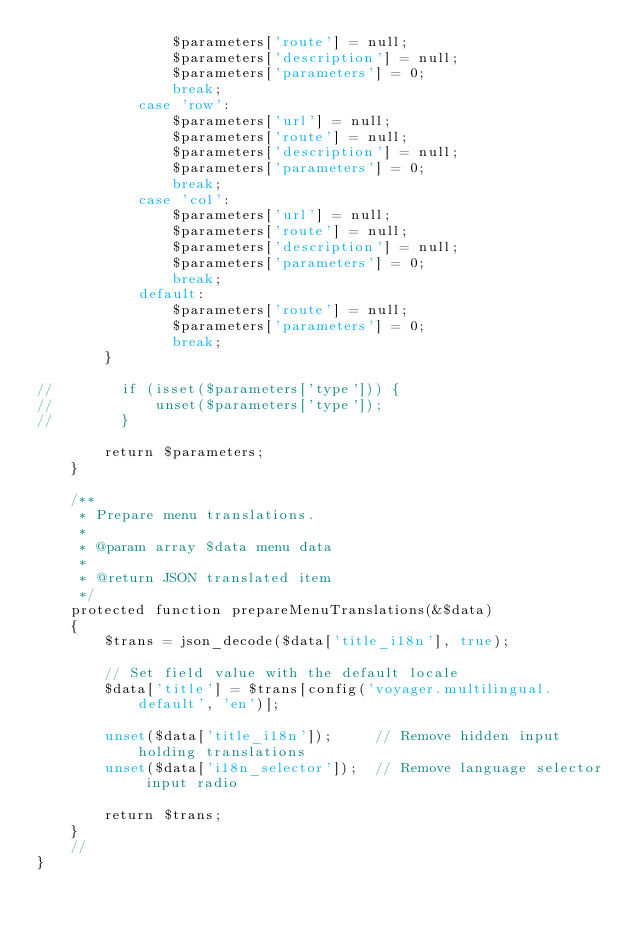Convert code to text. <code><loc_0><loc_0><loc_500><loc_500><_PHP_>                $parameters['route'] = null;
                $parameters['description'] = null;
                $parameters['parameters'] = 0;
                break;
            case 'row':
                $parameters['url'] = null;
                $parameters['route'] = null;
                $parameters['description'] = null;
                $parameters['parameters'] = 0;
                break;
            case 'col':
                $parameters['url'] = null;
                $parameters['route'] = null;
                $parameters['description'] = null;
                $parameters['parameters'] = 0;
                break;
            default:
                $parameters['route'] = null;
                $parameters['parameters'] = 0;
                break;
        }

//        if (isset($parameters['type'])) {
//            unset($parameters['type']);
//        }

        return $parameters;
    }

    /**
     * Prepare menu translations.
     *
     * @param array $data menu data
     *
     * @return JSON translated item
     */
    protected function prepareMenuTranslations(&$data)
    {
        $trans = json_decode($data['title_i18n'], true);

        // Set field value with the default locale
        $data['title'] = $trans[config('voyager.multilingual.default', 'en')];

        unset($data['title_i18n']);     // Remove hidden input holding translations
        unset($data['i18n_selector']);  // Remove language selector input radio

        return $trans;
    }
    //
}
</code> 